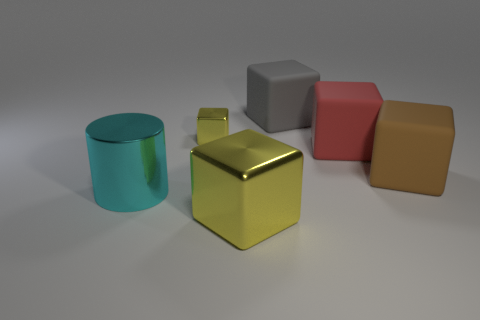Discuss the lighting used in this scene. What effect does it have? The scene is illuminated by a soft overhead light, which casts gentle shadows directly underneath each object. This lighting creates a calm atmosphere and accentuates the shapes and textures of the objects. It also enhances the visibility of their material properties – glossy surfaces reflect more light, while matte surfaces absorb it. 